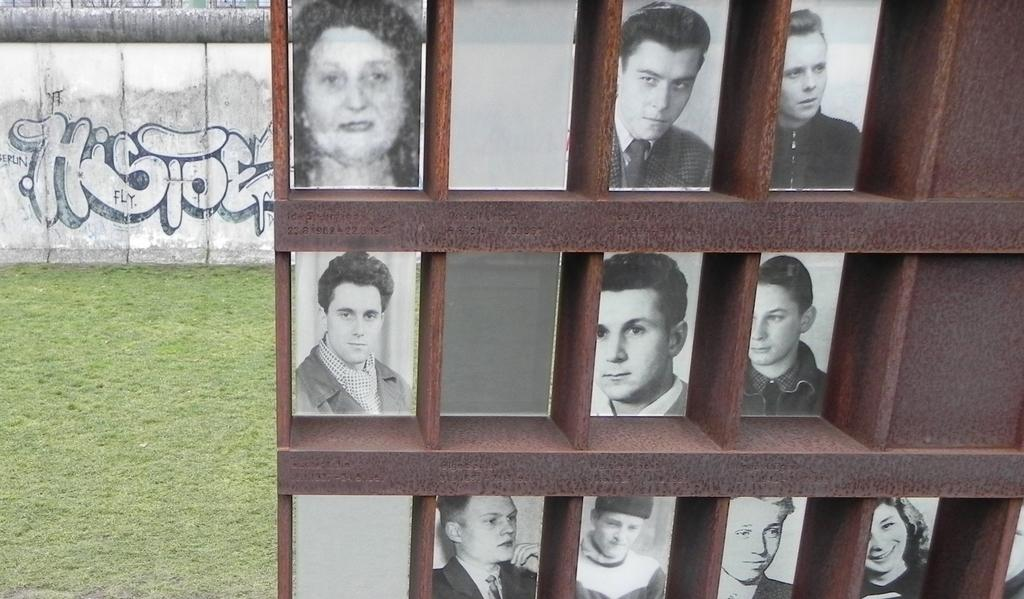What type of containers are present in the image? There are wooden boxes in the image. What can be found inside the wooden boxes? The wooden boxes contain photos of people. What type of vegetation is visible on the left side of the image? There is grass visible on the left side of the image. What can be seen on the wall in the top left corner of the image? There is a design on the wall in the top left corner of the image. Where are the kittens playing in the image? There are no kittens present in the image. What type of coil is wrapped around the wooden boxes in the image? There is no coil present in the image; the wooden boxes contain photos of people. 